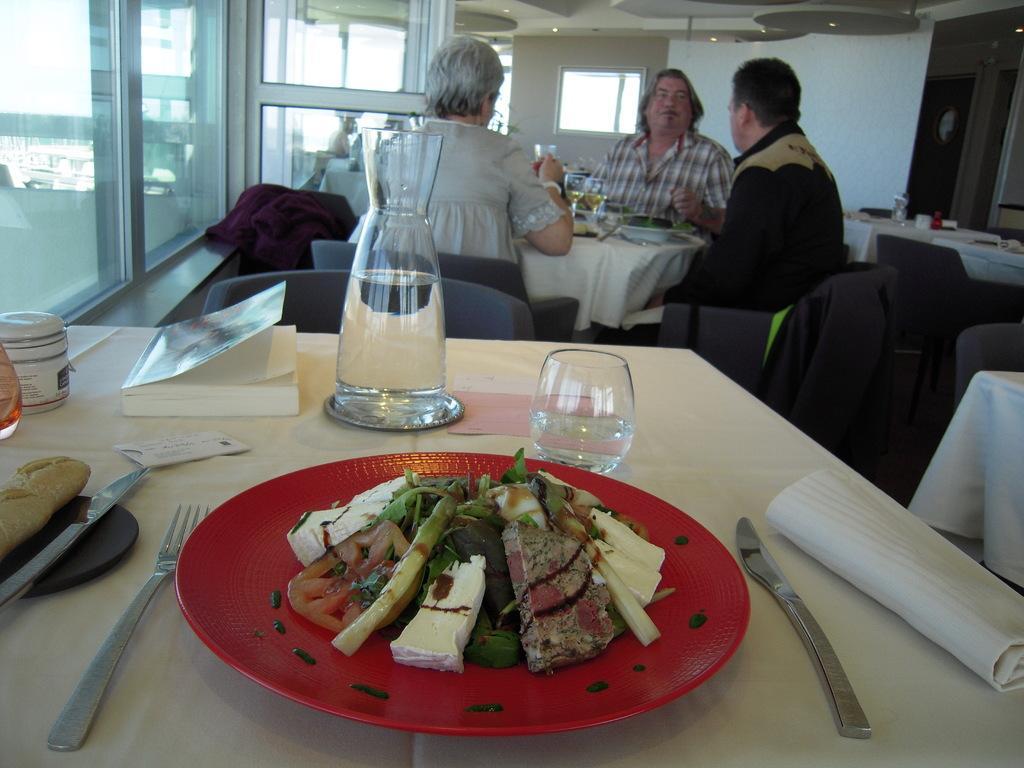Describe this image in one or two sentences. In this picture there are three people sitting on the chair. There is a glass, book, box, knife, fork, food in the plate , white cloth on the table. There are some lights and a maroon cloth. 